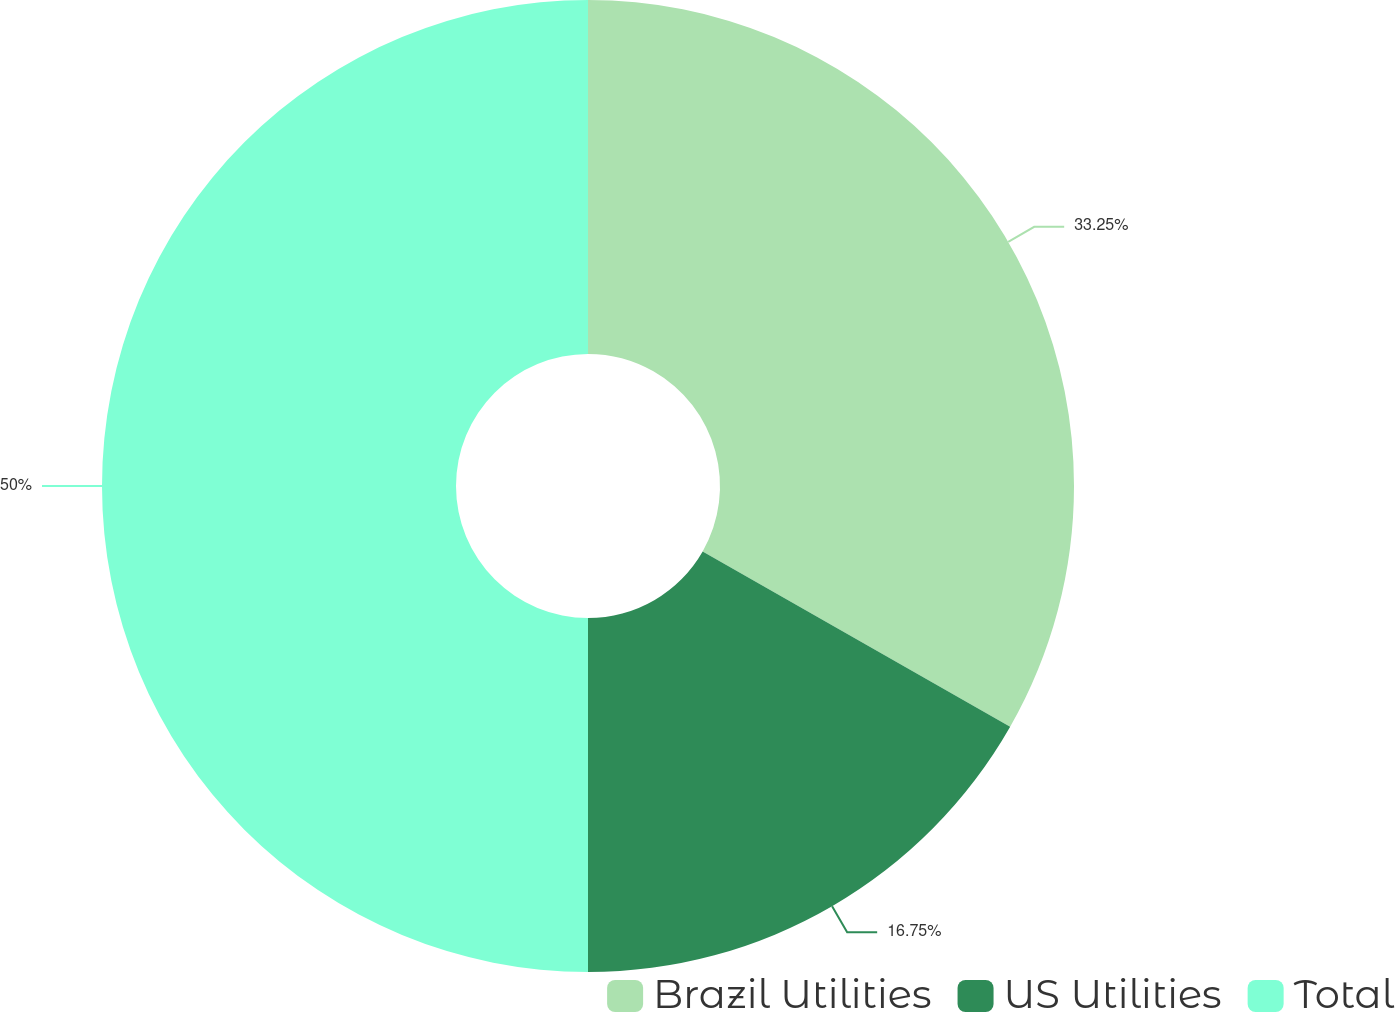Convert chart to OTSL. <chart><loc_0><loc_0><loc_500><loc_500><pie_chart><fcel>Brazil Utilities<fcel>US Utilities<fcel>Total<nl><fcel>33.25%<fcel>16.75%<fcel>50.0%<nl></chart> 